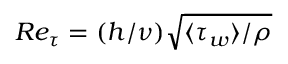<formula> <loc_0><loc_0><loc_500><loc_500>R e _ { \tau } = ( h / \nu ) \sqrt { \langle \tau _ { w } \rangle / \rho }</formula> 